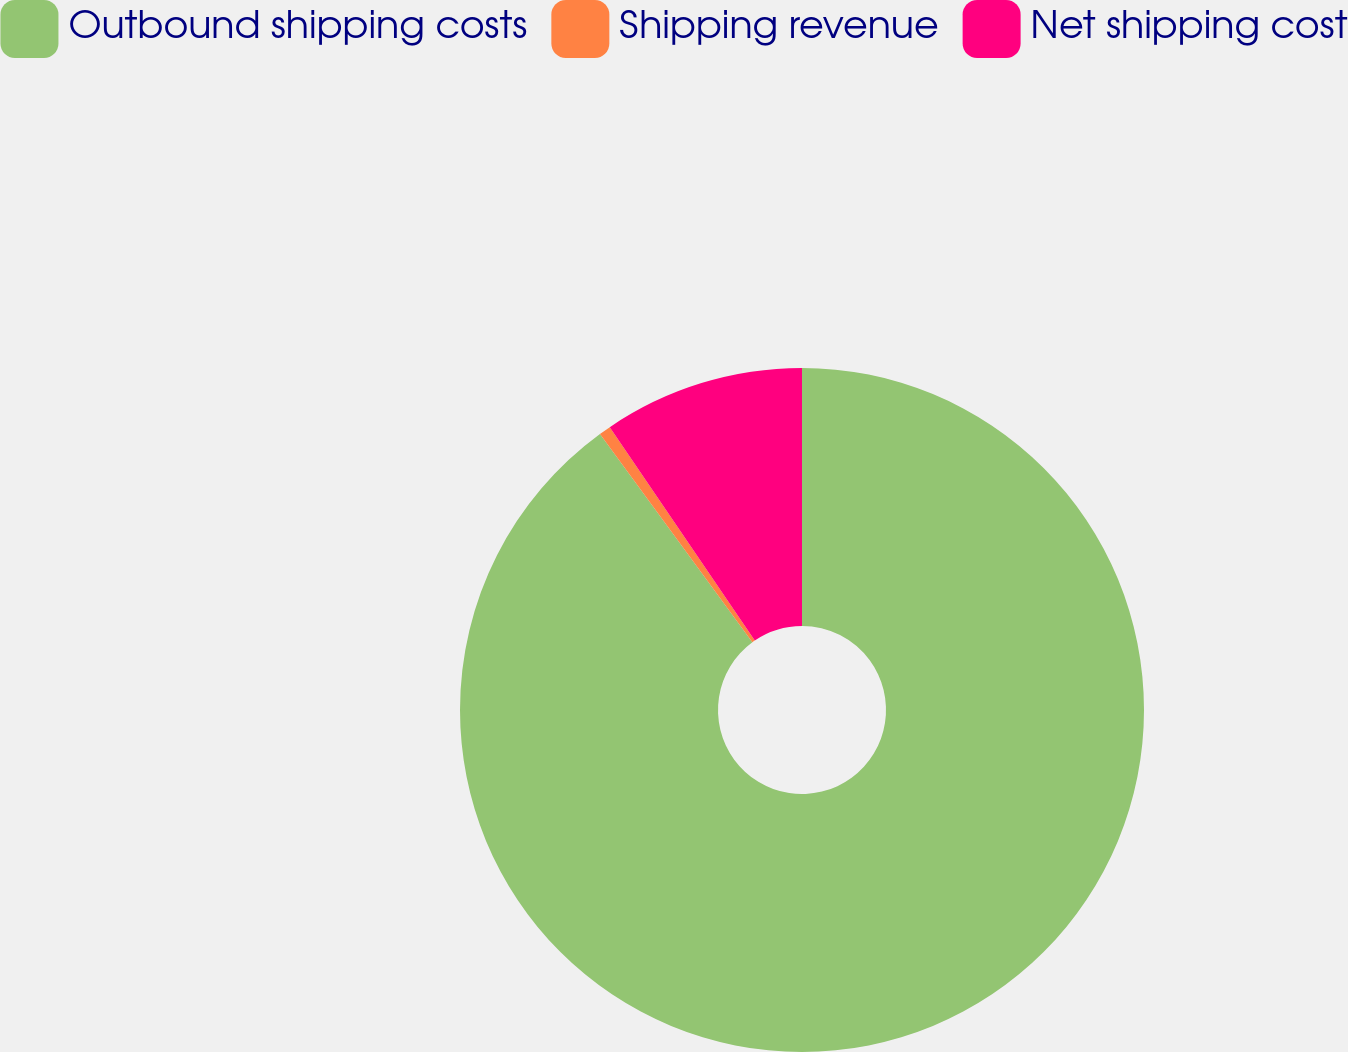Convert chart. <chart><loc_0><loc_0><loc_500><loc_500><pie_chart><fcel>Outbound shipping costs<fcel>Shipping revenue<fcel>Net shipping cost<nl><fcel>89.95%<fcel>0.56%<fcel>9.5%<nl></chart> 